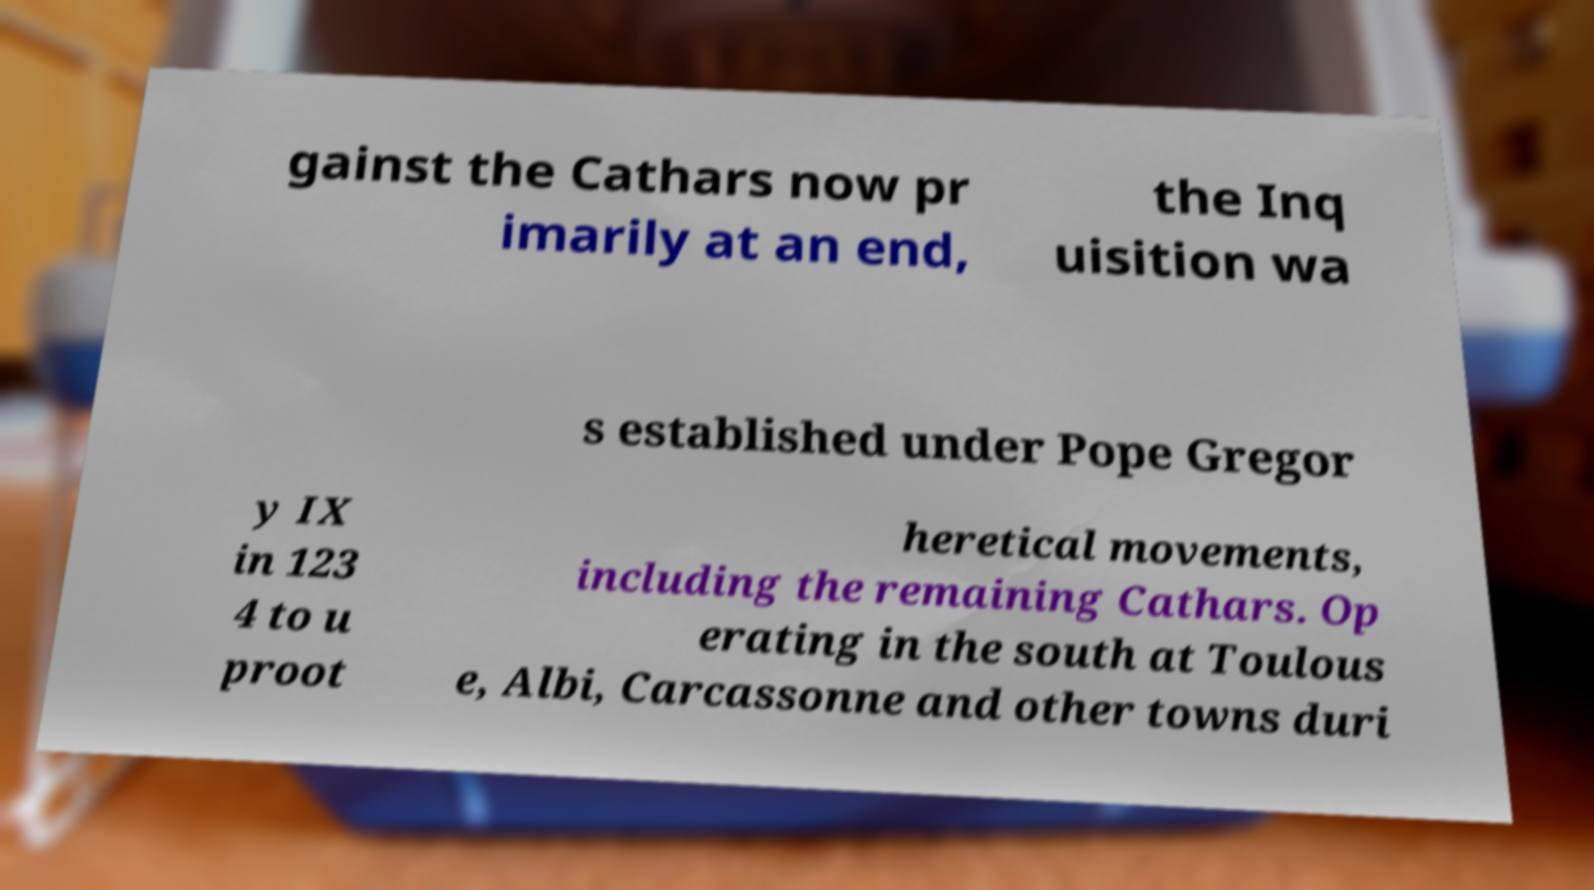I need the written content from this picture converted into text. Can you do that? gainst the Cathars now pr imarily at an end, the Inq uisition wa s established under Pope Gregor y IX in 123 4 to u proot heretical movements, including the remaining Cathars. Op erating in the south at Toulous e, Albi, Carcassonne and other towns duri 